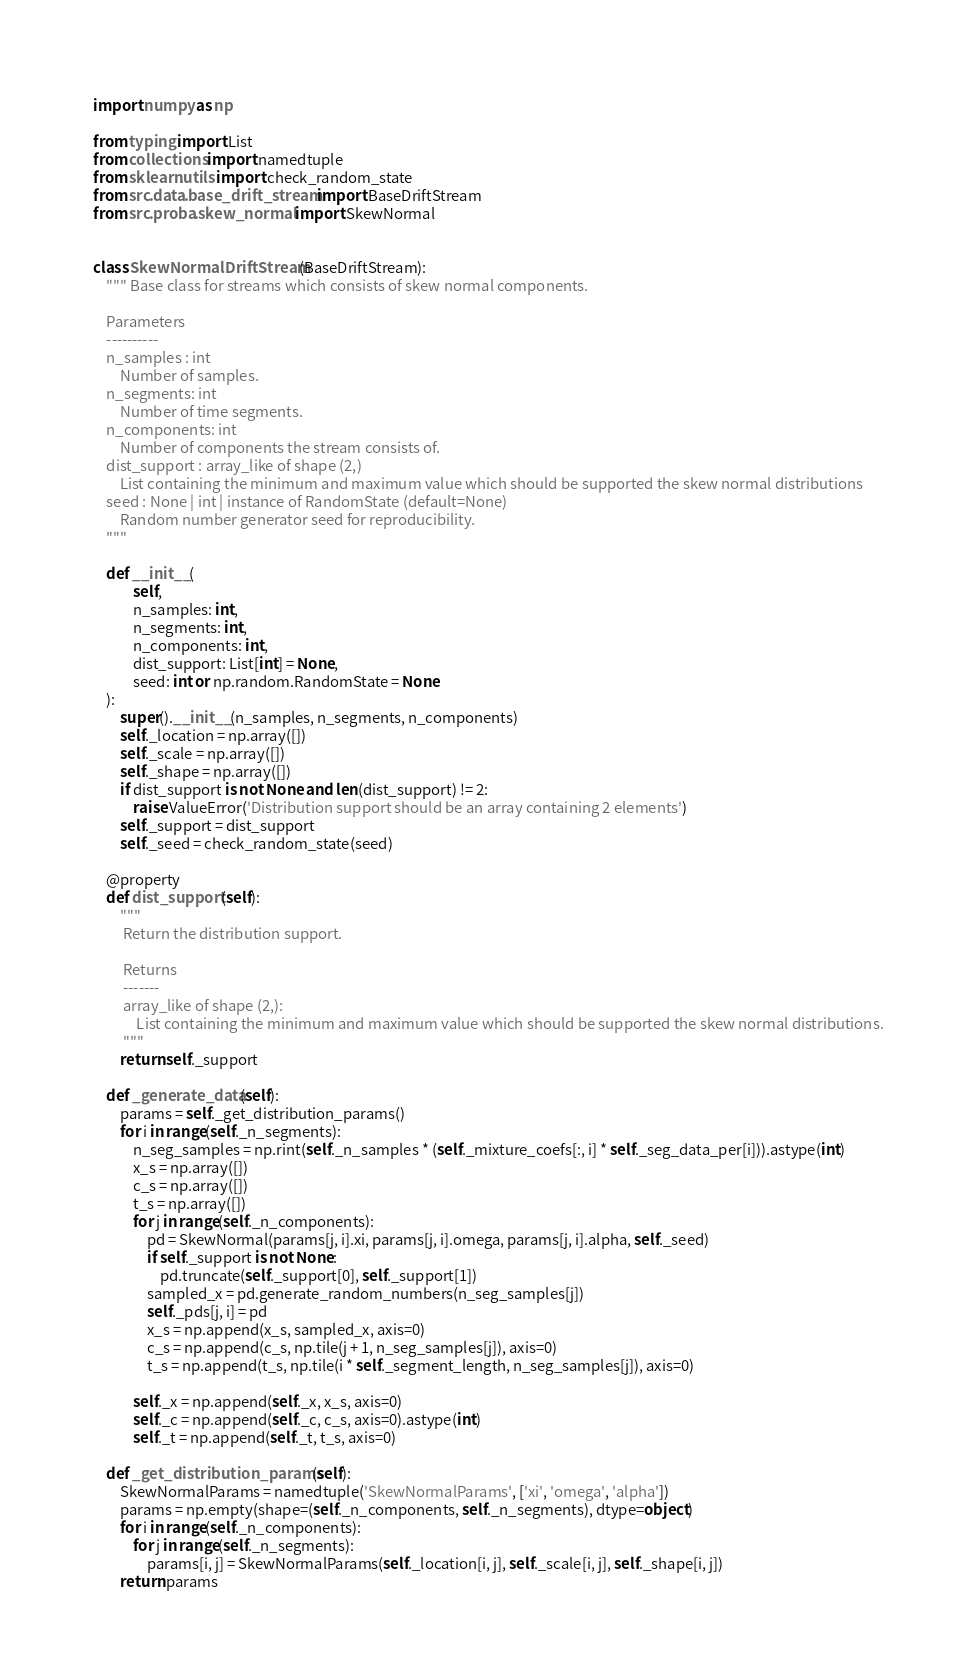Convert code to text. <code><loc_0><loc_0><loc_500><loc_500><_Python_>import numpy as np

from typing import List
from collections import namedtuple
from sklearn.utils import check_random_state
from src.data.base_drift_stream import BaseDriftStream
from src.proba.skew_normal import SkewNormal


class SkewNormalDriftStream(BaseDriftStream):
    """ Base class for streams which consists of skew normal components.

    Parameters
    ----------
    n_samples : int
        Number of samples.
    n_segments: int
        Number of time segments.
    n_components: int
        Number of components the stream consists of.
    dist_support : array_like of shape (2,)
        List containing the minimum and maximum value which should be supported the skew normal distributions
    seed : None | int | instance of RandomState (default=None)
        Random number generator seed for reproducibility.
    """

    def __init__(
            self,
            n_samples: int,
            n_segments: int,
            n_components: int,
            dist_support: List[int] = None,
            seed: int or np.random.RandomState = None
    ):
        super().__init__(n_samples, n_segments, n_components)
        self._location = np.array([])
        self._scale = np.array([])
        self._shape = np.array([])
        if dist_support is not None and len(dist_support) != 2:
            raise ValueError('Distribution support should be an array containing 2 elements')
        self._support = dist_support
        self._seed = check_random_state(seed)

    @property
    def dist_support(self):
        """
         Return the distribution support.

         Returns
         -------
         array_like of shape (2,):
             List containing the minimum and maximum value which should be supported the skew normal distributions.
         """
        return self._support

    def _generate_data(self):
        params = self._get_distribution_params()
        for i in range(self._n_segments):
            n_seg_samples = np.rint(self._n_samples * (self._mixture_coefs[:, i] * self._seg_data_per[i])).astype(int)
            x_s = np.array([])
            c_s = np.array([])
            t_s = np.array([])
            for j in range(self._n_components):
                pd = SkewNormal(params[j, i].xi, params[j, i].omega, params[j, i].alpha, self._seed)
                if self._support is not None:
                    pd.truncate(self._support[0], self._support[1])
                sampled_x = pd.generate_random_numbers(n_seg_samples[j])
                self._pds[j, i] = pd
                x_s = np.append(x_s, sampled_x, axis=0)
                c_s = np.append(c_s, np.tile(j + 1, n_seg_samples[j]), axis=0)
                t_s = np.append(t_s, np.tile(i * self._segment_length, n_seg_samples[j]), axis=0)

            self._x = np.append(self._x, x_s, axis=0)
            self._c = np.append(self._c, c_s, axis=0).astype(int)
            self._t = np.append(self._t, t_s, axis=0)

    def _get_distribution_params(self):
        SkewNormalParams = namedtuple('SkewNormalParams', ['xi', 'omega', 'alpha'])
        params = np.empty(shape=(self._n_components, self._n_segments), dtype=object)
        for i in range(self._n_components):
            for j in range(self._n_segments):
                params[i, j] = SkewNormalParams(self._location[i, j], self._scale[i, j], self._shape[i, j])
        return params
</code> 